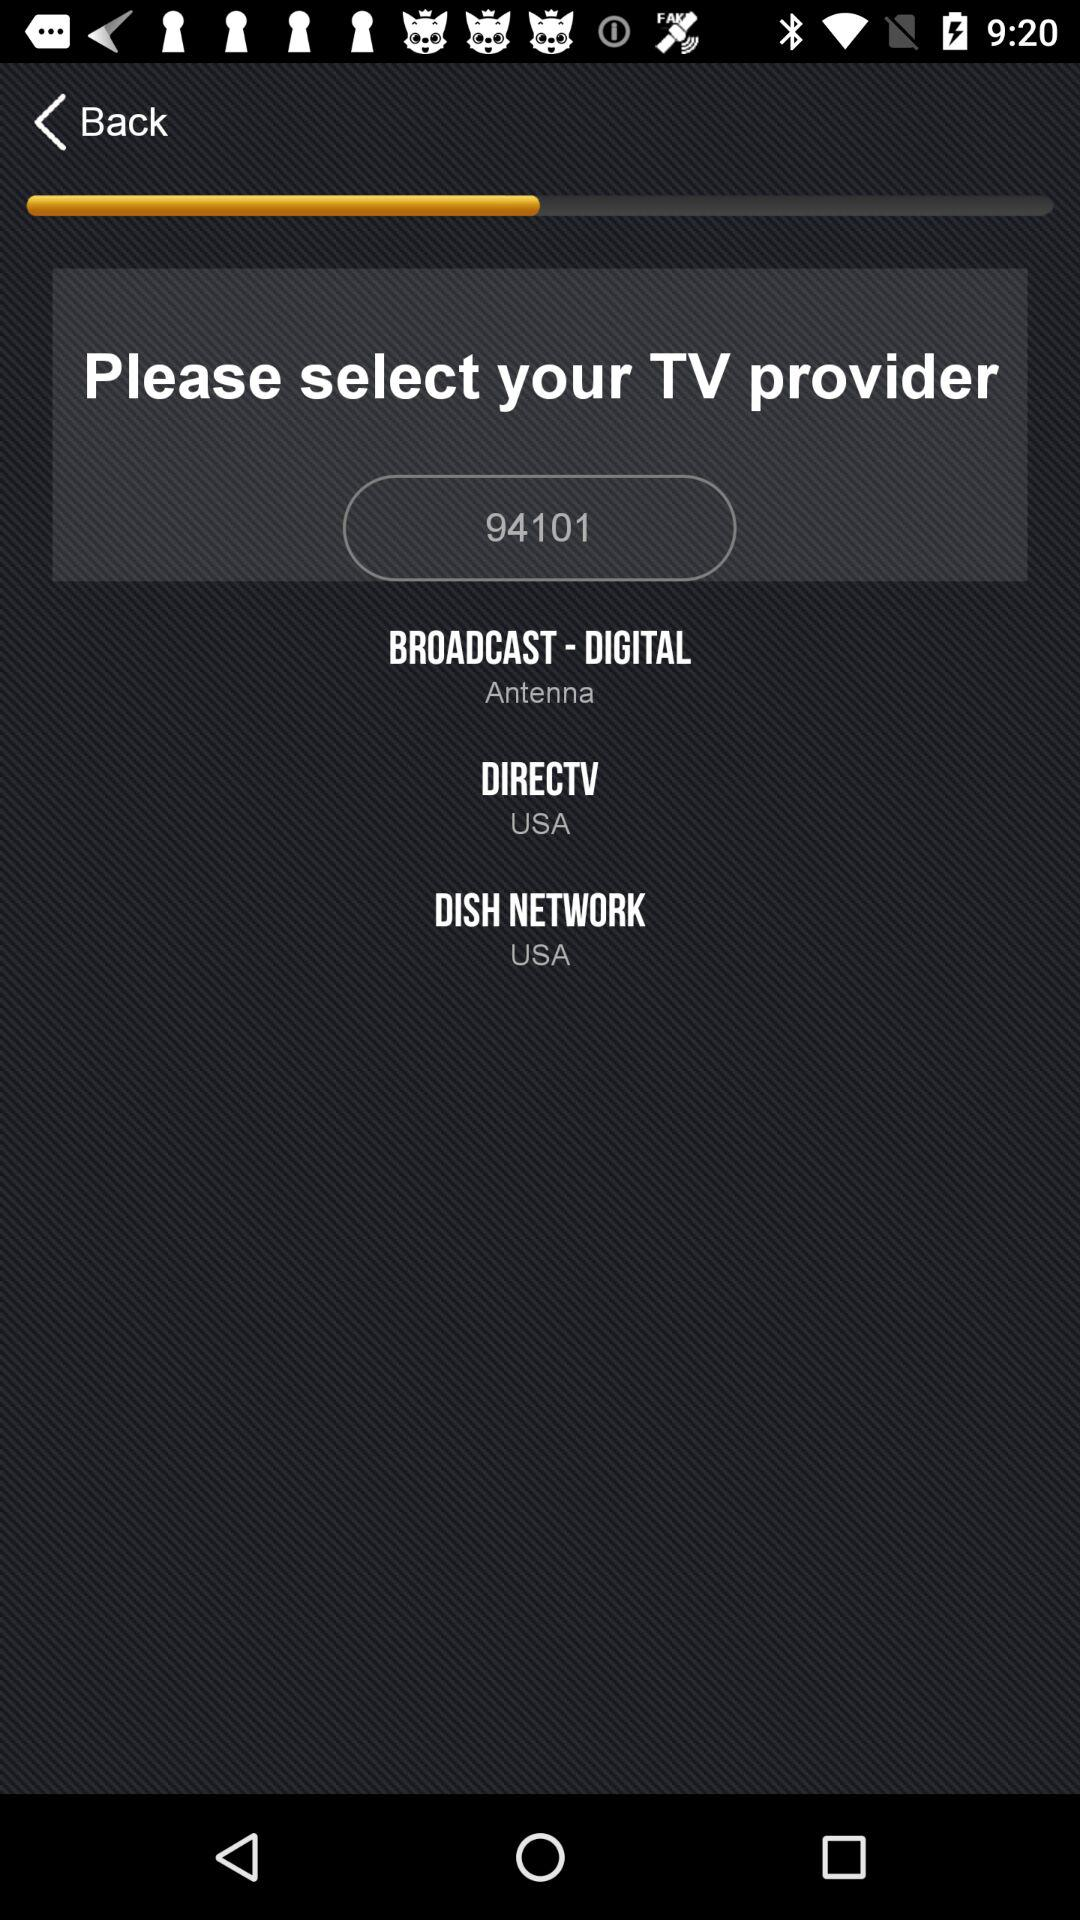What dish network is selected? The dish network is "USA". 